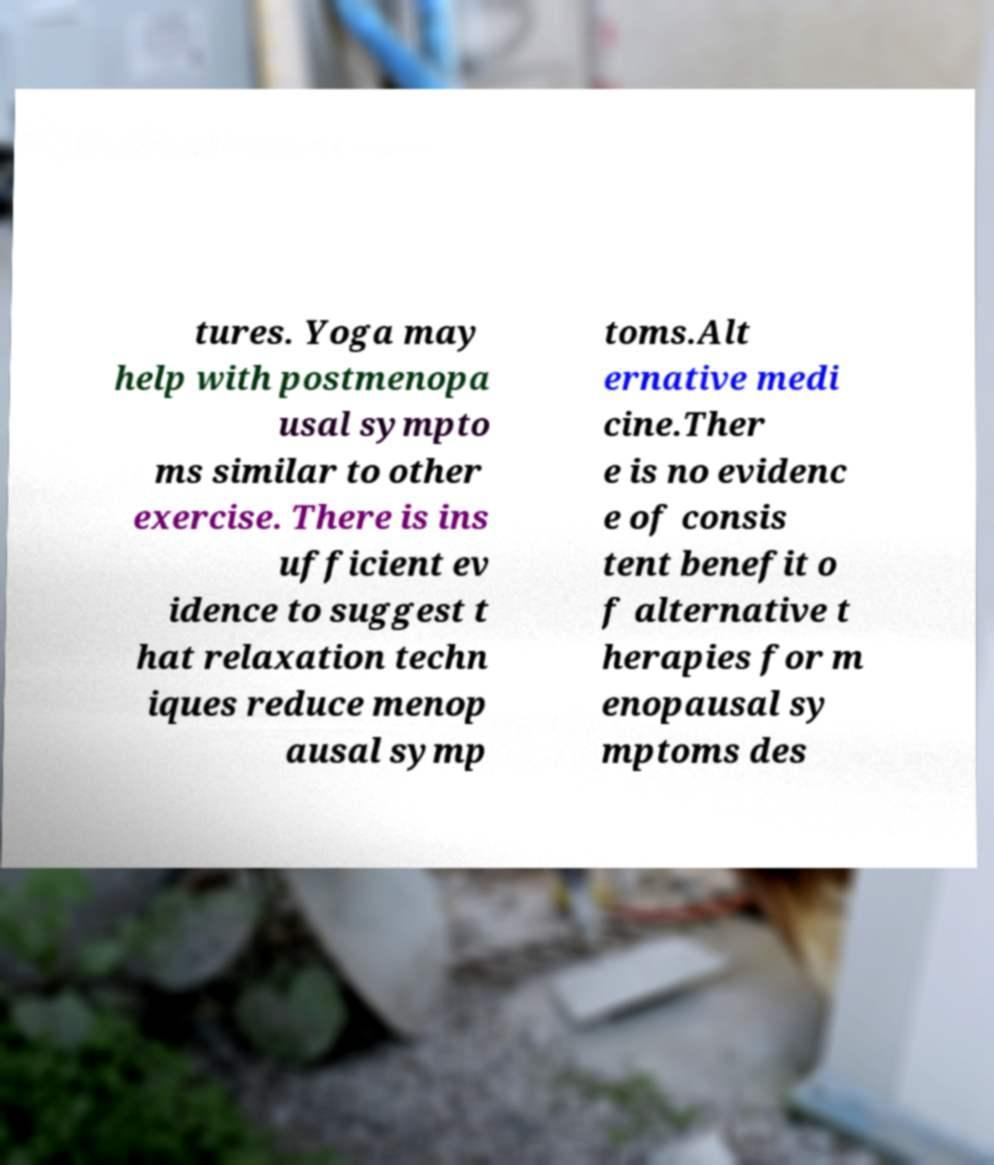Could you extract and type out the text from this image? tures. Yoga may help with postmenopa usal sympto ms similar to other exercise. There is ins ufficient ev idence to suggest t hat relaxation techn iques reduce menop ausal symp toms.Alt ernative medi cine.Ther e is no evidenc e of consis tent benefit o f alternative t herapies for m enopausal sy mptoms des 